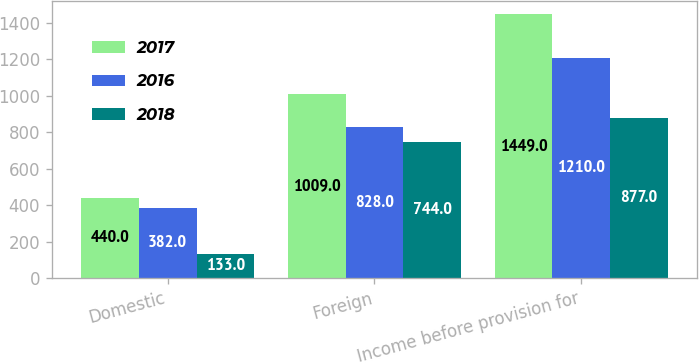Convert chart to OTSL. <chart><loc_0><loc_0><loc_500><loc_500><stacked_bar_chart><ecel><fcel>Domestic<fcel>Foreign<fcel>Income before provision for<nl><fcel>2017<fcel>440<fcel>1009<fcel>1449<nl><fcel>2016<fcel>382<fcel>828<fcel>1210<nl><fcel>2018<fcel>133<fcel>744<fcel>877<nl></chart> 